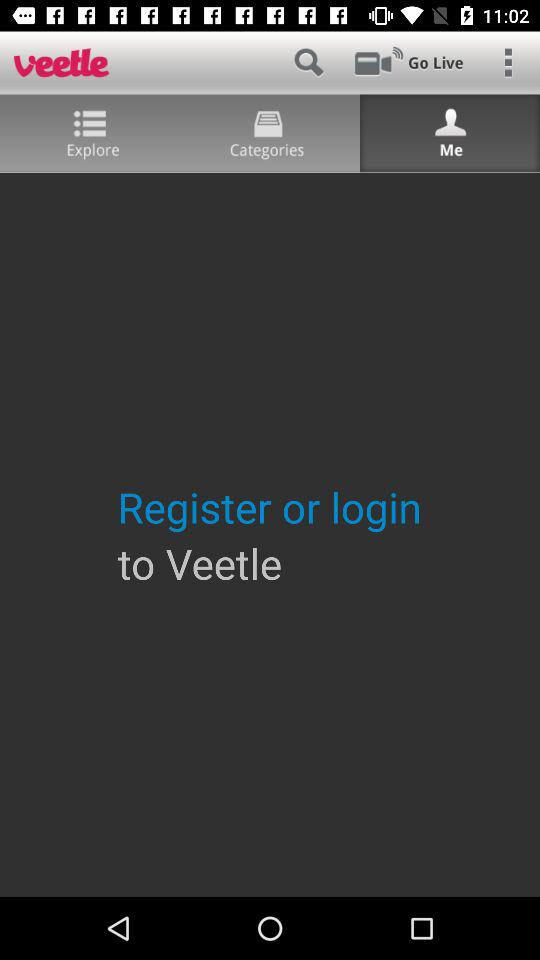What is the application name? The application name is "veetle". 